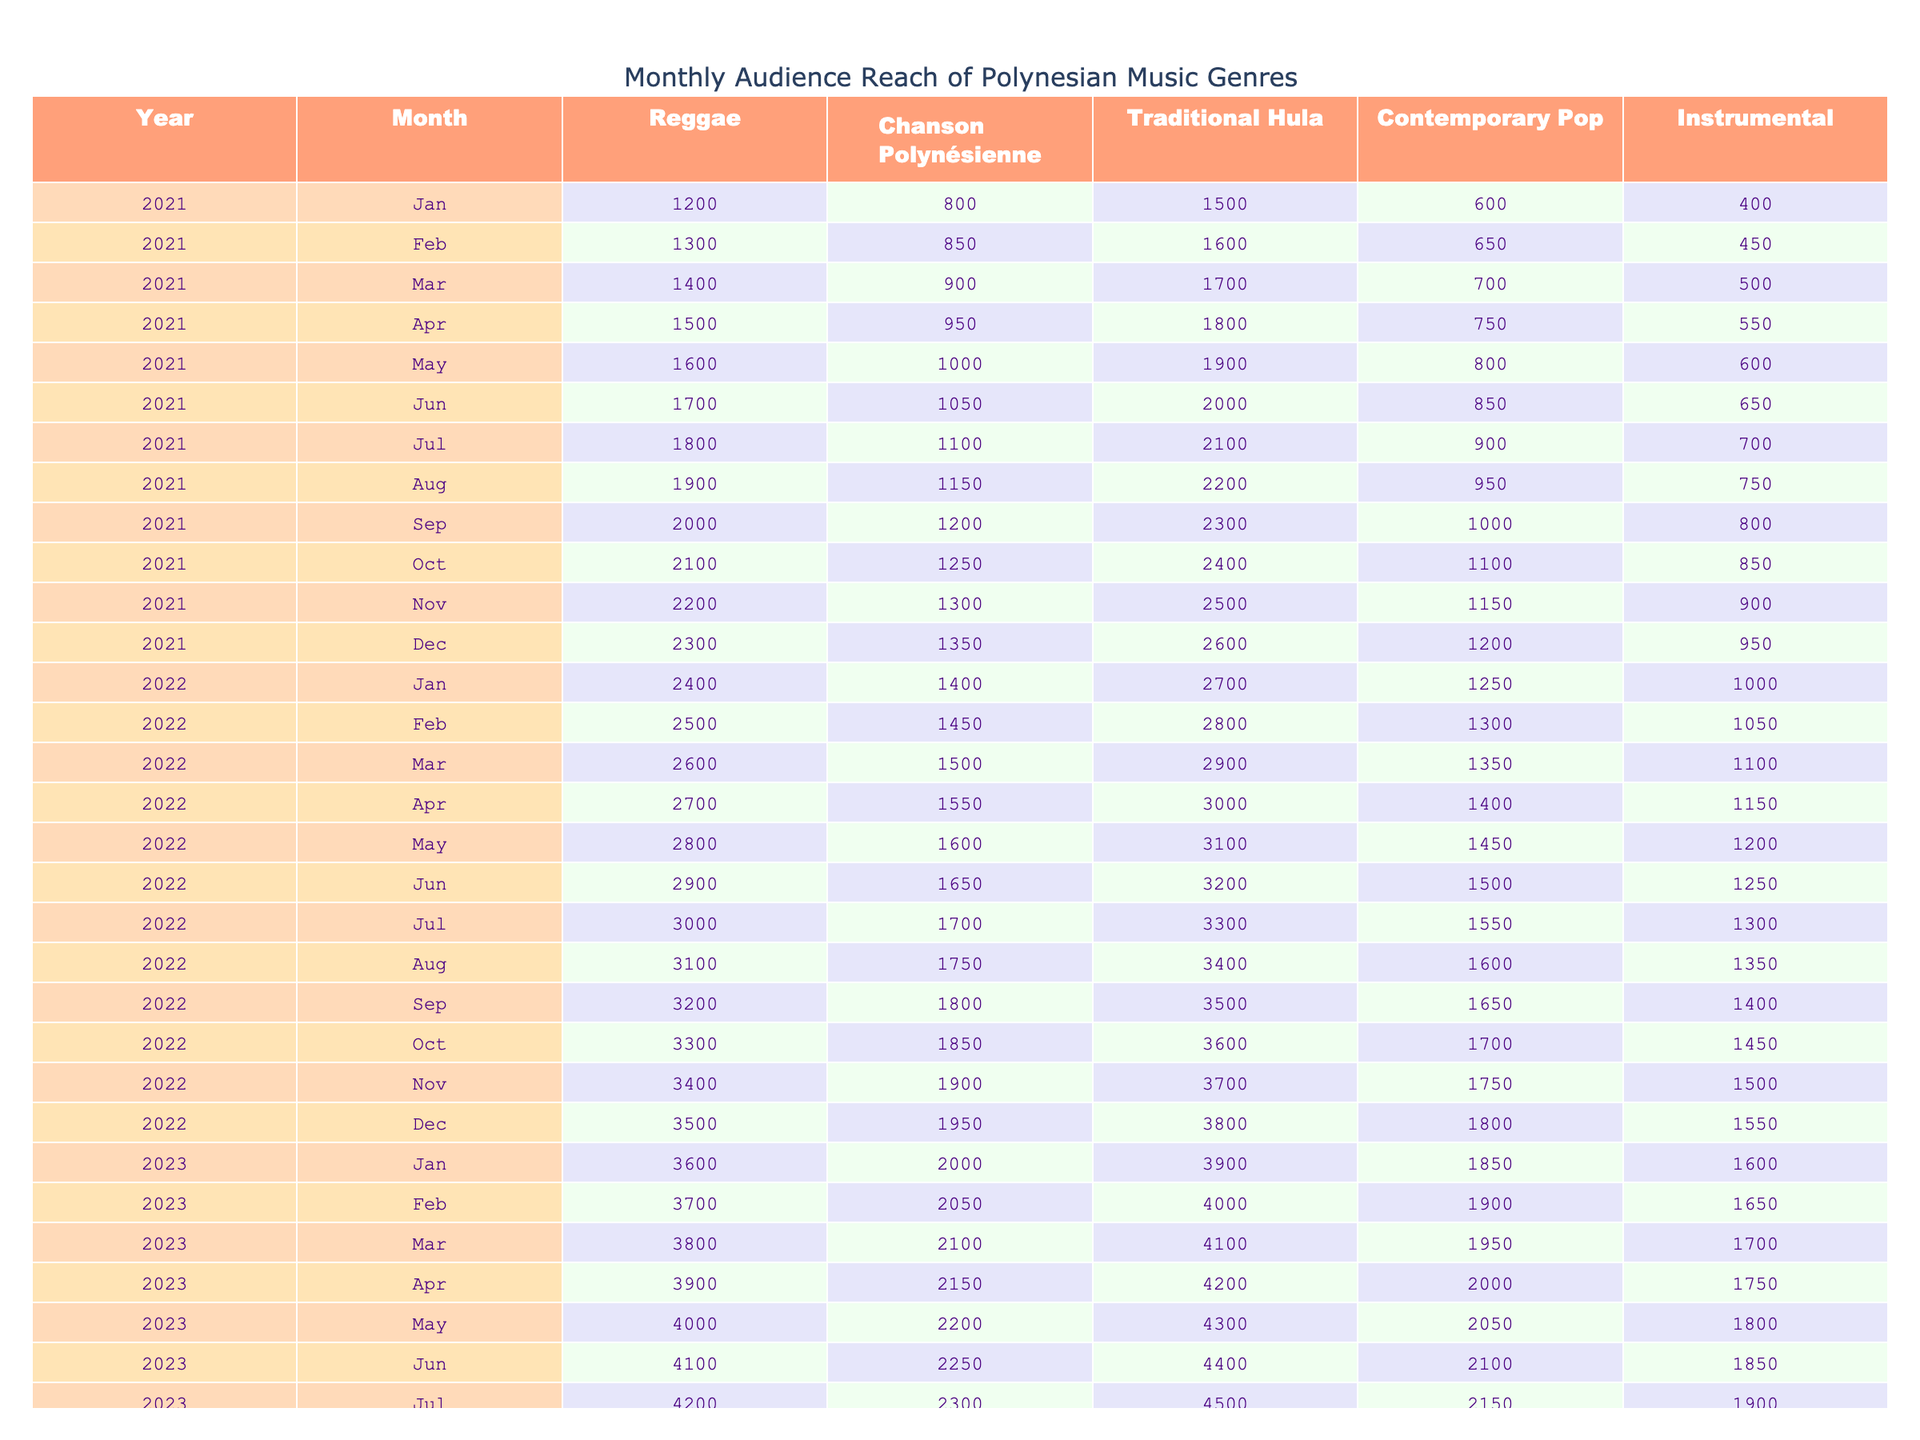What was the audience reach for Contemporary Pop in January 2022? Looking at the table for January 2022, the value listed under Contemporary Pop is 1250.
Answer: 1250 Which month in 2021 had the highest audience reach for Traditional Hula? In 2021, the highest audience reach for Traditional Hula was in December, with a value of 2600.
Answer: December 2021 What is the difference in audience reach for Reggae between March 2023 and March 2021? The audience reach for Reggae in March 2023 is 3800 and in March 2021 is 1400. The difference is 3800 - 1400 = 2400.
Answer: 2400 What genre had the lowest audience reach in June 2022? In June 2022, the lowest audience reach was for Instrumental, which had a value of 1250.
Answer: Instrumental What was the average audience reach for Chanson Polynésienne from January 2021 to December 2022? The total audience reach for Chanson Polynésienne across 24 months is calculated as follows: 800 + 850 + ... + 1950 = 31600. Then, the average is 31600 / 24 = 1316.67.
Answer: Approximately 1317 Which genre saw the largest increase in audience reach from January 2021 to January 2023? For January 2021, the audience reach for Reggae was 1200, and for January 2023, it was 3600. The increase is 3600 - 1200 = 2400. Checking other genres, Reggae has the largest increase.
Answer: Reggae Did the audience reach for Instrumental in April 2022 exceed 1200? In April 2022, the audience reach for Instrumental is 1150, which does not exceed 1200.
Answer: No What is the total audience reach for all genres in October 2022? Adding the values for all genres in October 2022 gives 3400 (Reggae) + 1900 (Chanson Polynésienne) + 3700 (Traditional Hula) + 1750 (Contemporary Pop) + 1500 (Instrumental) = 13250.
Answer: 13250 Which month had a greater audience reach for Contemporary Pop, March 2022 or March 2023? In March 2022, Contemporary Pop had an audience reach of 1350, whereas in March 2023, it reached 1950. Therefore, March 2023 had a greater audience reach.
Answer: March 2023 What percentage did the audience reach for Traditional Hula increase from January 2022 to January 2023? The audience reach for Traditional Hula was 2700 in January 2022 and 3900 in January 2023. The increase is (3900 - 2700) / 2700 * 100 = 44.44%.
Answer: 44.44% Which genre consistently had the highest audience reach throughout the entire year of 2022? By checking the monthly data for each genre in 2022, Traditional Hula consistently had the highest reach every month, starting from 2700 in January to 3800 in December.
Answer: Traditional Hula 